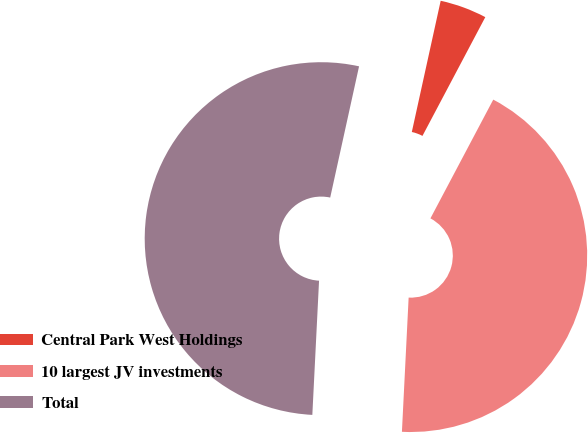Convert chart to OTSL. <chart><loc_0><loc_0><loc_500><loc_500><pie_chart><fcel>Central Park West Holdings<fcel>10 largest JV investments<fcel>Total<nl><fcel>4.3%<fcel>43.05%<fcel>52.65%<nl></chart> 